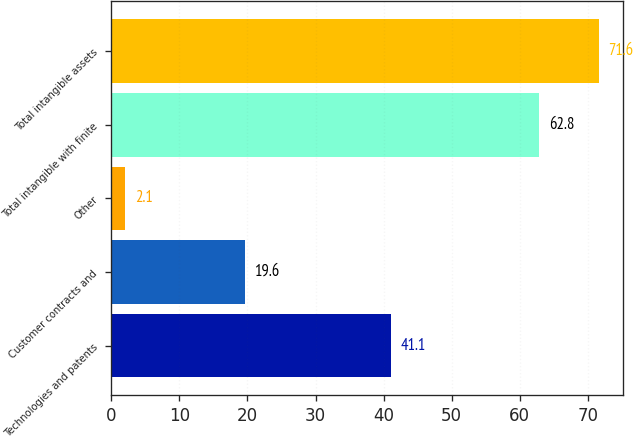<chart> <loc_0><loc_0><loc_500><loc_500><bar_chart><fcel>Technologies and patents<fcel>Customer contracts and<fcel>Other<fcel>Total intangible with finite<fcel>Total intangible assets<nl><fcel>41.1<fcel>19.6<fcel>2.1<fcel>62.8<fcel>71.6<nl></chart> 